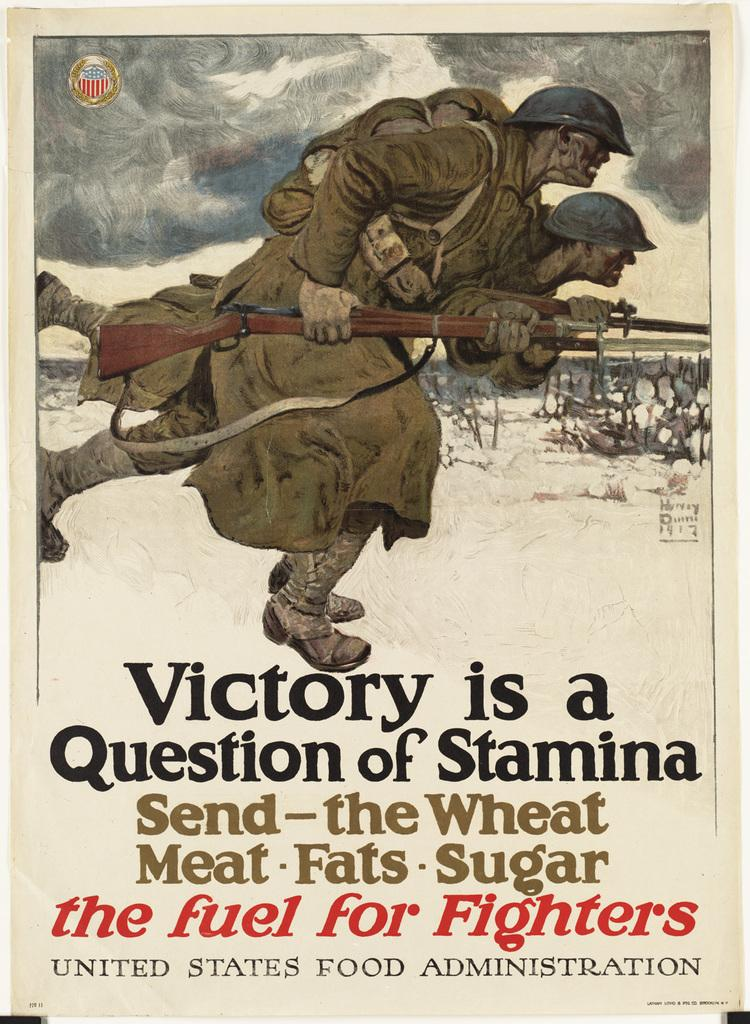<image>
Describe the image concisely. A grim poster by the U.S Food Administration urges people  to support war efforts by sending food to fuel the fighters. 